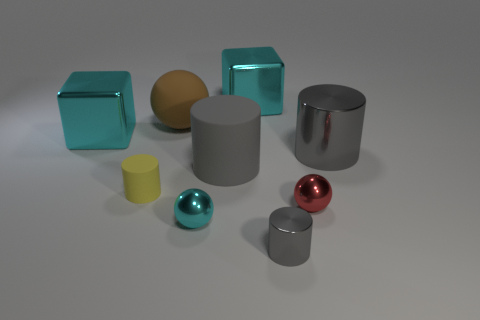What number of rubber cylinders are the same size as the rubber ball?
Offer a terse response. 1. Is the tiny matte object the same color as the small metallic cylinder?
Your response must be concise. No. Are the gray cylinder to the right of the tiny metallic cylinder and the ball behind the big gray metal cylinder made of the same material?
Your answer should be compact. No. Is the number of large balls greater than the number of gray cylinders?
Make the answer very short. No. Are there any other things that have the same color as the big sphere?
Give a very brief answer. No. Is the material of the cyan sphere the same as the brown thing?
Provide a succinct answer. No. Is the number of cyan metallic spheres less than the number of brown cubes?
Offer a very short reply. No. Is the shape of the yellow matte thing the same as the big gray metal object?
Offer a very short reply. Yes. What is the color of the tiny shiny cylinder?
Offer a very short reply. Gray. How many other objects are there of the same material as the big brown ball?
Provide a succinct answer. 2. 